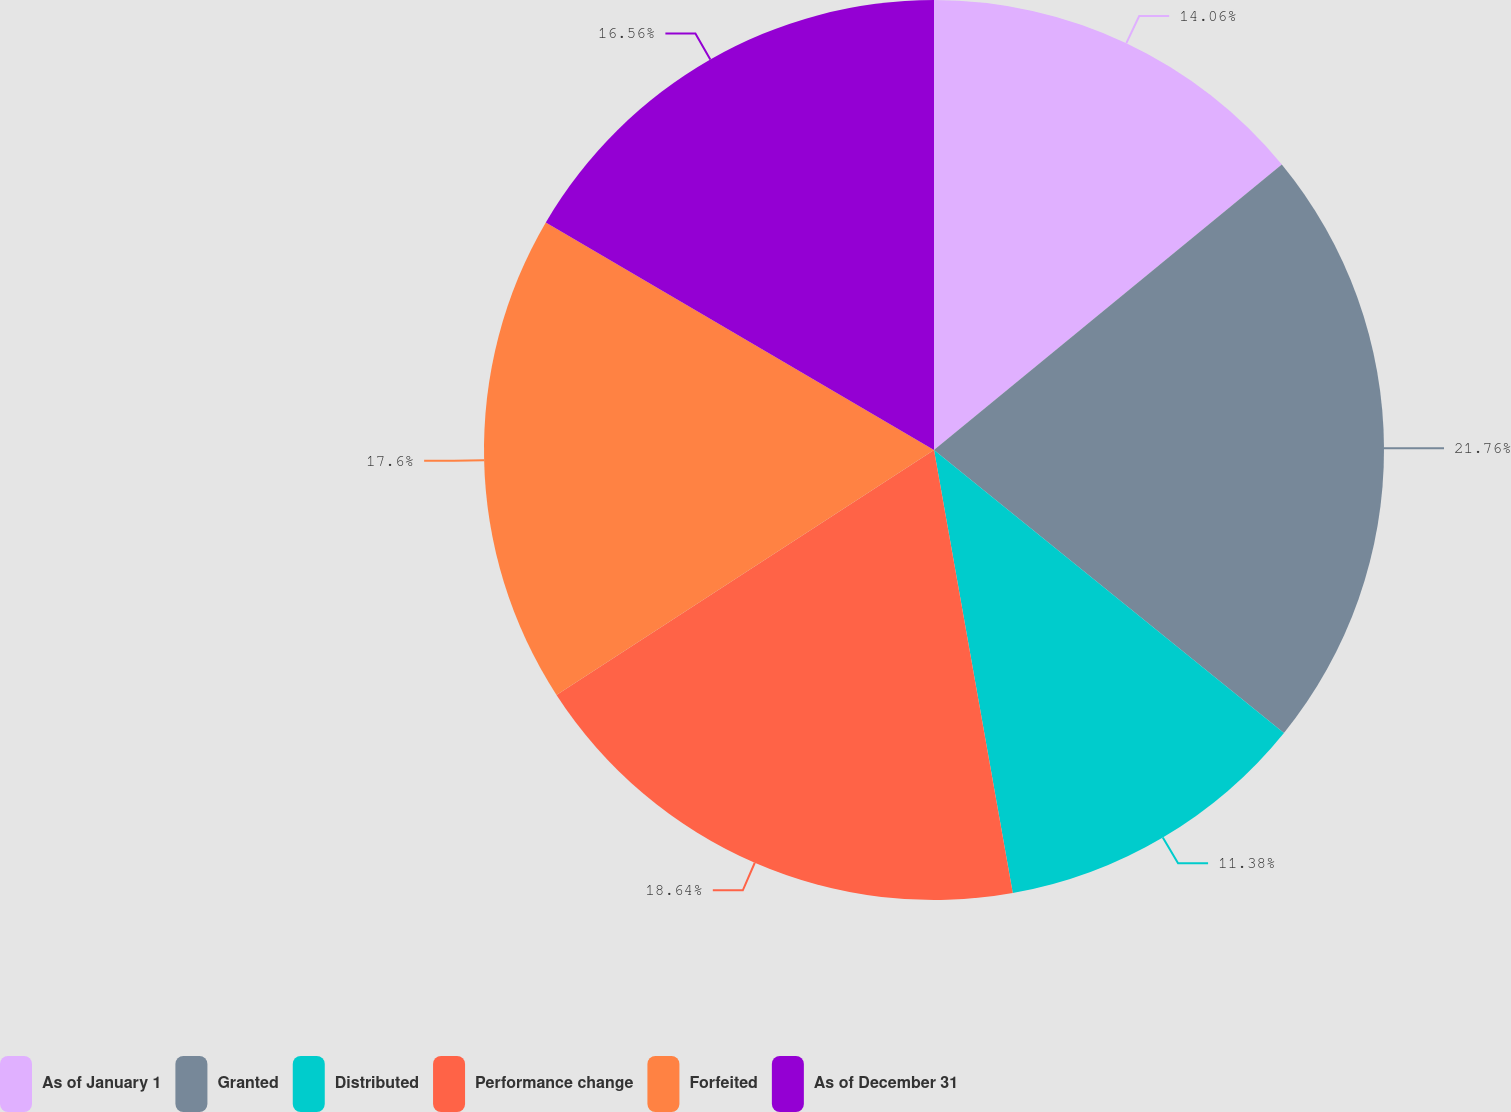<chart> <loc_0><loc_0><loc_500><loc_500><pie_chart><fcel>As of January 1<fcel>Granted<fcel>Distributed<fcel>Performance change<fcel>Forfeited<fcel>As of December 31<nl><fcel>14.06%<fcel>21.76%<fcel>11.38%<fcel>18.64%<fcel>17.6%<fcel>16.56%<nl></chart> 